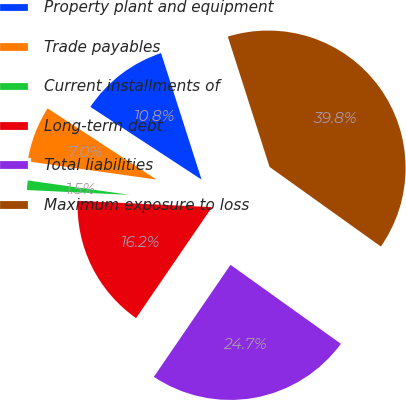<chart> <loc_0><loc_0><loc_500><loc_500><pie_chart><fcel>Property plant and equipment<fcel>Trade payables<fcel>Current installments of<fcel>Long-term debt<fcel>Total liabilities<fcel>Maximum exposure to loss<nl><fcel>10.85%<fcel>6.98%<fcel>1.49%<fcel>16.2%<fcel>24.67%<fcel>39.82%<nl></chart> 